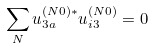Convert formula to latex. <formula><loc_0><loc_0><loc_500><loc_500>\sum _ { N } u _ { 3 a } ^ { ( N 0 ) * } u _ { i 3 } ^ { ( N 0 ) } = 0</formula> 